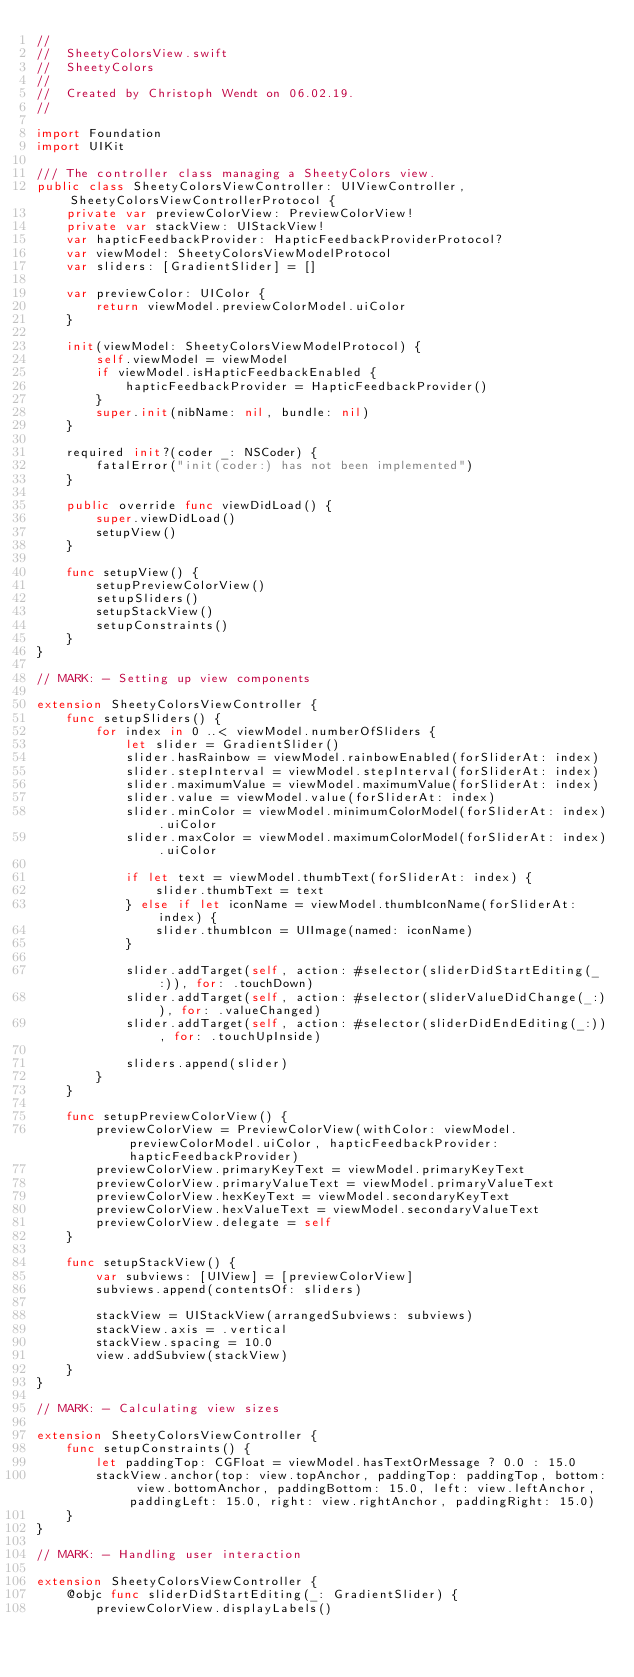Convert code to text. <code><loc_0><loc_0><loc_500><loc_500><_Swift_>//
//  SheetyColorsView.swift
//  SheetyColors
//
//  Created by Christoph Wendt on 06.02.19.
//

import Foundation
import UIKit

/// The controller class managing a SheetyColors view.
public class SheetyColorsViewController: UIViewController, SheetyColorsViewControllerProtocol {
    private var previewColorView: PreviewColorView!
    private var stackView: UIStackView!
    var hapticFeedbackProvider: HapticFeedbackProviderProtocol?
    var viewModel: SheetyColorsViewModelProtocol
    var sliders: [GradientSlider] = []

    var previewColor: UIColor {
        return viewModel.previewColorModel.uiColor
    }

    init(viewModel: SheetyColorsViewModelProtocol) {
        self.viewModel = viewModel
        if viewModel.isHapticFeedbackEnabled {
            hapticFeedbackProvider = HapticFeedbackProvider()
        }
        super.init(nibName: nil, bundle: nil)
    }

    required init?(coder _: NSCoder) {
        fatalError("init(coder:) has not been implemented")
    }

    public override func viewDidLoad() {
        super.viewDidLoad()
        setupView()
    }

    func setupView() {
        setupPreviewColorView()
        setupSliders()
        setupStackView()
        setupConstraints()
    }
}

// MARK: - Setting up view components

extension SheetyColorsViewController {
    func setupSliders() {
        for index in 0 ..< viewModel.numberOfSliders {
            let slider = GradientSlider()
            slider.hasRainbow = viewModel.rainbowEnabled(forSliderAt: index)
            slider.stepInterval = viewModel.stepInterval(forSliderAt: index)
            slider.maximumValue = viewModel.maximumValue(forSliderAt: index)
            slider.value = viewModel.value(forSliderAt: index)
            slider.minColor = viewModel.minimumColorModel(forSliderAt: index).uiColor
            slider.maxColor = viewModel.maximumColorModel(forSliderAt: index).uiColor

            if let text = viewModel.thumbText(forSliderAt: index) {
                slider.thumbText = text
            } else if let iconName = viewModel.thumbIconName(forSliderAt: index) {
                slider.thumbIcon = UIImage(named: iconName)
            }

            slider.addTarget(self, action: #selector(sliderDidStartEditing(_:)), for: .touchDown)
            slider.addTarget(self, action: #selector(sliderValueDidChange(_:)), for: .valueChanged)
            slider.addTarget(self, action: #selector(sliderDidEndEditing(_:)), for: .touchUpInside)

            sliders.append(slider)
        }
    }

    func setupPreviewColorView() {
        previewColorView = PreviewColorView(withColor: viewModel.previewColorModel.uiColor, hapticFeedbackProvider: hapticFeedbackProvider)
        previewColorView.primaryKeyText = viewModel.primaryKeyText
        previewColorView.primaryValueText = viewModel.primaryValueText
        previewColorView.hexKeyText = viewModel.secondaryKeyText
        previewColorView.hexValueText = viewModel.secondaryValueText
        previewColorView.delegate = self
    }

    func setupStackView() {
        var subviews: [UIView] = [previewColorView]
        subviews.append(contentsOf: sliders)

        stackView = UIStackView(arrangedSubviews: subviews)
        stackView.axis = .vertical
        stackView.spacing = 10.0
        view.addSubview(stackView)
    }
}

// MARK: - Calculating view sizes

extension SheetyColorsViewController {
    func setupConstraints() {
        let paddingTop: CGFloat = viewModel.hasTextOrMessage ? 0.0 : 15.0
        stackView.anchor(top: view.topAnchor, paddingTop: paddingTop, bottom: view.bottomAnchor, paddingBottom: 15.0, left: view.leftAnchor, paddingLeft: 15.0, right: view.rightAnchor, paddingRight: 15.0)
    }
}

// MARK: - Handling user interaction

extension SheetyColorsViewController {
    @objc func sliderDidStartEditing(_: GradientSlider) {
        previewColorView.displayLabels()</code> 